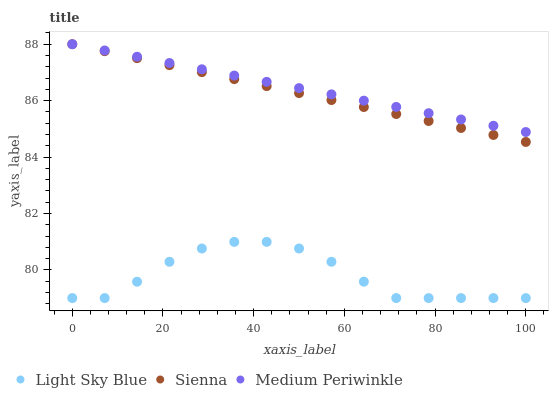Does Light Sky Blue have the minimum area under the curve?
Answer yes or no. Yes. Does Medium Periwinkle have the maximum area under the curve?
Answer yes or no. Yes. Does Medium Periwinkle have the minimum area under the curve?
Answer yes or no. No. Does Light Sky Blue have the maximum area under the curve?
Answer yes or no. No. Is Sienna the smoothest?
Answer yes or no. Yes. Is Light Sky Blue the roughest?
Answer yes or no. Yes. Is Medium Periwinkle the smoothest?
Answer yes or no. No. Is Medium Periwinkle the roughest?
Answer yes or no. No. Does Light Sky Blue have the lowest value?
Answer yes or no. Yes. Does Medium Periwinkle have the lowest value?
Answer yes or no. No. Does Medium Periwinkle have the highest value?
Answer yes or no. Yes. Does Light Sky Blue have the highest value?
Answer yes or no. No. Is Light Sky Blue less than Medium Periwinkle?
Answer yes or no. Yes. Is Sienna greater than Light Sky Blue?
Answer yes or no. Yes. Does Sienna intersect Medium Periwinkle?
Answer yes or no. Yes. Is Sienna less than Medium Periwinkle?
Answer yes or no. No. Is Sienna greater than Medium Periwinkle?
Answer yes or no. No. Does Light Sky Blue intersect Medium Periwinkle?
Answer yes or no. No. 